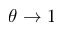<formula> <loc_0><loc_0><loc_500><loc_500>\theta \rightarrow 1</formula> 